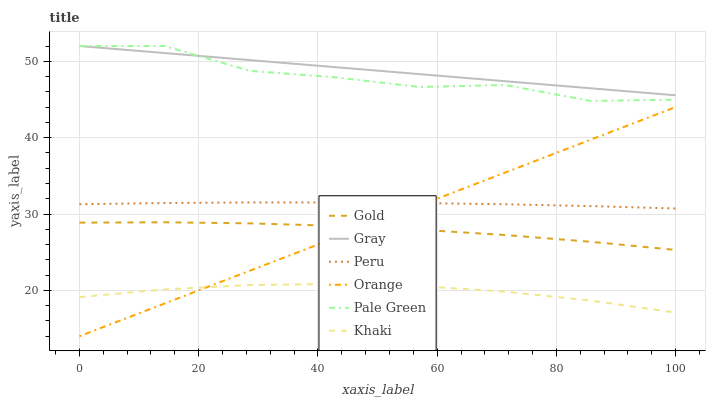Does Khaki have the minimum area under the curve?
Answer yes or no. Yes. Does Gray have the maximum area under the curve?
Answer yes or no. Yes. Does Gold have the minimum area under the curve?
Answer yes or no. No. Does Gold have the maximum area under the curve?
Answer yes or no. No. Is Gray the smoothest?
Answer yes or no. Yes. Is Pale Green the roughest?
Answer yes or no. Yes. Is Khaki the smoothest?
Answer yes or no. No. Is Khaki the roughest?
Answer yes or no. No. Does Orange have the lowest value?
Answer yes or no. Yes. Does Khaki have the lowest value?
Answer yes or no. No. Does Pale Green have the highest value?
Answer yes or no. Yes. Does Gold have the highest value?
Answer yes or no. No. Is Orange less than Gray?
Answer yes or no. Yes. Is Pale Green greater than Orange?
Answer yes or no. Yes. Does Peru intersect Orange?
Answer yes or no. Yes. Is Peru less than Orange?
Answer yes or no. No. Is Peru greater than Orange?
Answer yes or no. No. Does Orange intersect Gray?
Answer yes or no. No. 